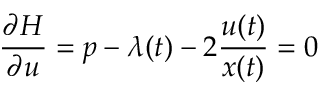<formula> <loc_0><loc_0><loc_500><loc_500>{ \frac { \partial H } { \partial u } } = p - \lambda ( t ) - 2 { \frac { u ( t ) } { x ( t ) } } = 0</formula> 